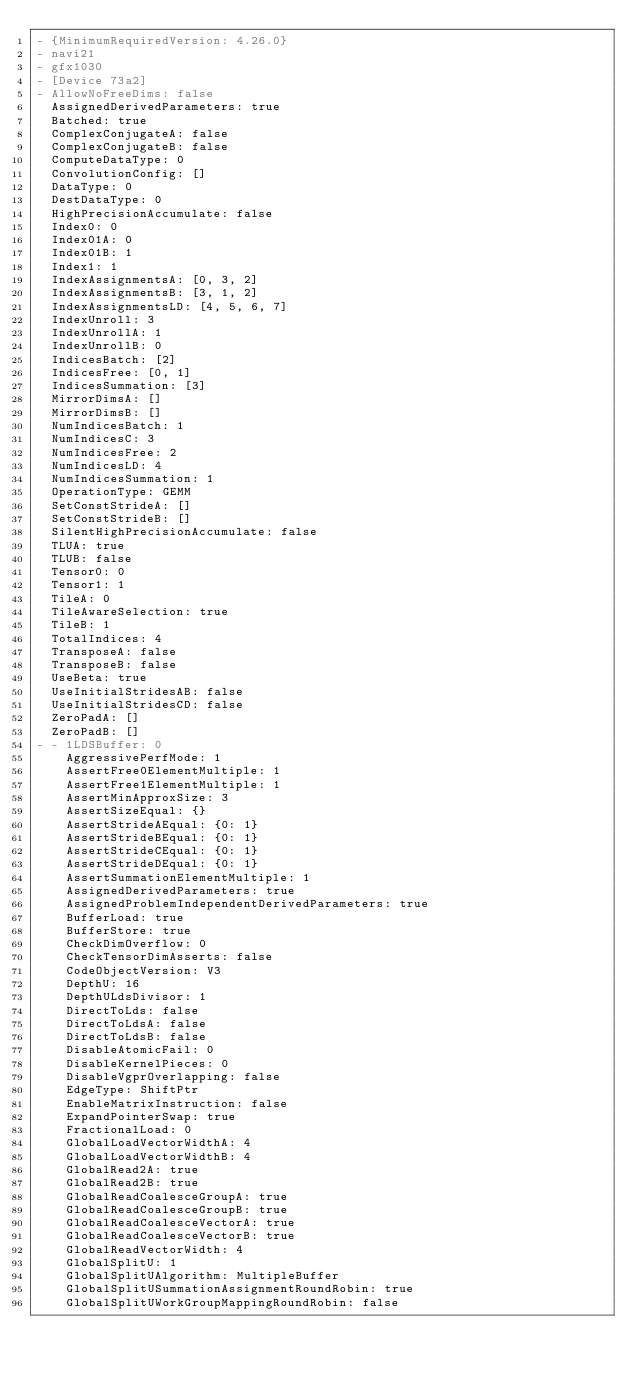<code> <loc_0><loc_0><loc_500><loc_500><_YAML_>- {MinimumRequiredVersion: 4.26.0}
- navi21
- gfx1030
- [Device 73a2]
- AllowNoFreeDims: false
  AssignedDerivedParameters: true
  Batched: true
  ComplexConjugateA: false
  ComplexConjugateB: false
  ComputeDataType: 0
  ConvolutionConfig: []
  DataType: 0
  DestDataType: 0
  HighPrecisionAccumulate: false
  Index0: 0
  Index01A: 0
  Index01B: 1
  Index1: 1
  IndexAssignmentsA: [0, 3, 2]
  IndexAssignmentsB: [3, 1, 2]
  IndexAssignmentsLD: [4, 5, 6, 7]
  IndexUnroll: 3
  IndexUnrollA: 1
  IndexUnrollB: 0
  IndicesBatch: [2]
  IndicesFree: [0, 1]
  IndicesSummation: [3]
  MirrorDimsA: []
  MirrorDimsB: []
  NumIndicesBatch: 1
  NumIndicesC: 3
  NumIndicesFree: 2
  NumIndicesLD: 4
  NumIndicesSummation: 1
  OperationType: GEMM
  SetConstStrideA: []
  SetConstStrideB: []
  SilentHighPrecisionAccumulate: false
  TLUA: true
  TLUB: false
  Tensor0: 0
  Tensor1: 1
  TileA: 0
  TileAwareSelection: true
  TileB: 1
  TotalIndices: 4
  TransposeA: false
  TransposeB: false
  UseBeta: true
  UseInitialStridesAB: false
  UseInitialStridesCD: false
  ZeroPadA: []
  ZeroPadB: []
- - 1LDSBuffer: 0
    AggressivePerfMode: 1
    AssertFree0ElementMultiple: 1
    AssertFree1ElementMultiple: 1
    AssertMinApproxSize: 3
    AssertSizeEqual: {}
    AssertStrideAEqual: {0: 1}
    AssertStrideBEqual: {0: 1}
    AssertStrideCEqual: {0: 1}
    AssertStrideDEqual: {0: 1}
    AssertSummationElementMultiple: 1
    AssignedDerivedParameters: true
    AssignedProblemIndependentDerivedParameters: true
    BufferLoad: true
    BufferStore: true
    CheckDimOverflow: 0
    CheckTensorDimAsserts: false
    CodeObjectVersion: V3
    DepthU: 16
    DepthULdsDivisor: 1
    DirectToLds: false
    DirectToLdsA: false
    DirectToLdsB: false
    DisableAtomicFail: 0
    DisableKernelPieces: 0
    DisableVgprOverlapping: false
    EdgeType: ShiftPtr
    EnableMatrixInstruction: false
    ExpandPointerSwap: true
    FractionalLoad: 0
    GlobalLoadVectorWidthA: 4
    GlobalLoadVectorWidthB: 4
    GlobalRead2A: true
    GlobalRead2B: true
    GlobalReadCoalesceGroupA: true
    GlobalReadCoalesceGroupB: true
    GlobalReadCoalesceVectorA: true
    GlobalReadCoalesceVectorB: true
    GlobalReadVectorWidth: 4
    GlobalSplitU: 1
    GlobalSplitUAlgorithm: MultipleBuffer
    GlobalSplitUSummationAssignmentRoundRobin: true
    GlobalSplitUWorkGroupMappingRoundRobin: false</code> 